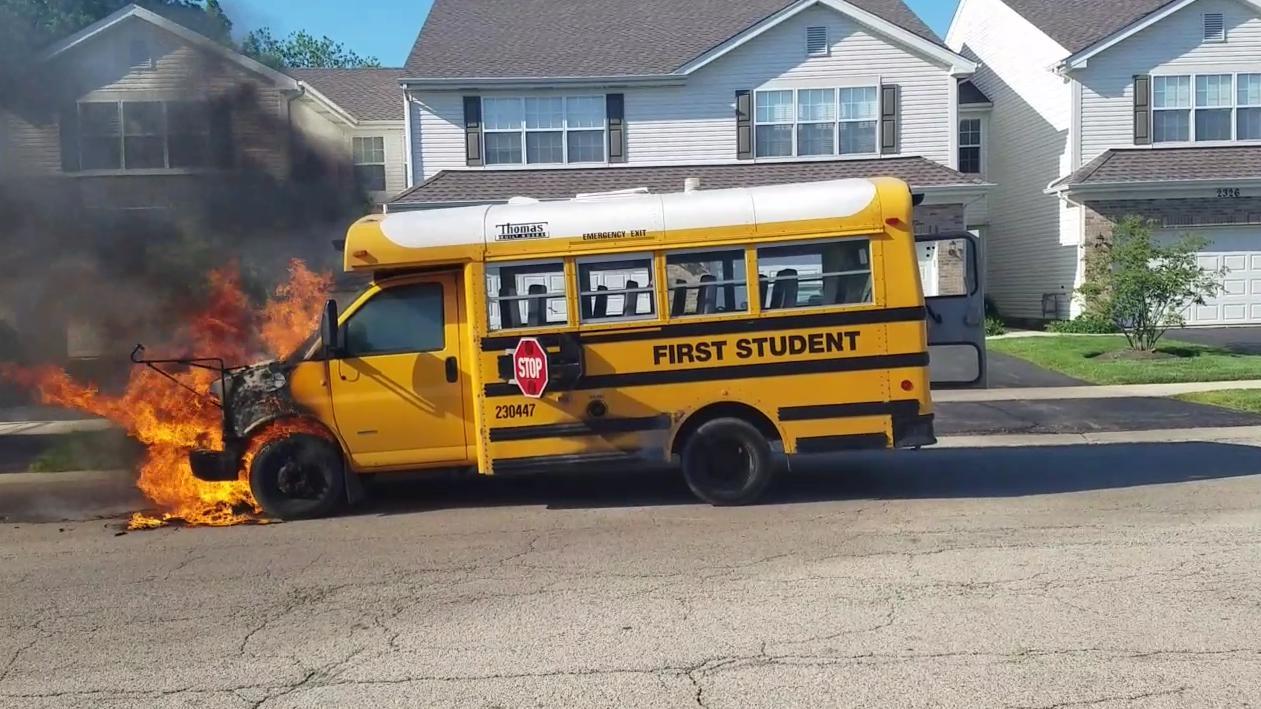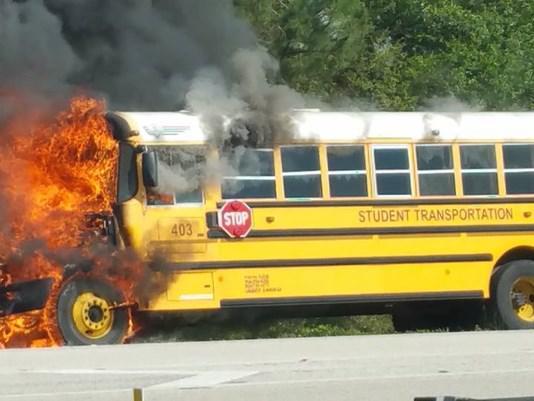The first image is the image on the left, the second image is the image on the right. Evaluate the accuracy of this statement regarding the images: "In at least one image, a fire is blazing at the front of a bus parked with its red stop sign facing the camera.". Is it true? Answer yes or no. Yes. The first image is the image on the left, the second image is the image on the right. Considering the images on both sides, is "At least one of the schoolbusses is on fire." valid? Answer yes or no. Yes. 